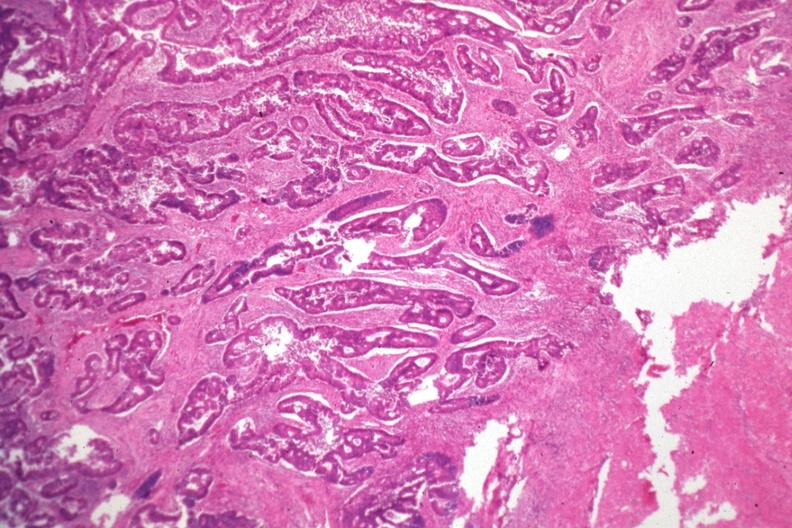does this image show typical infiltrating adenocarcinoma?
Answer the question using a single word or phrase. Yes 